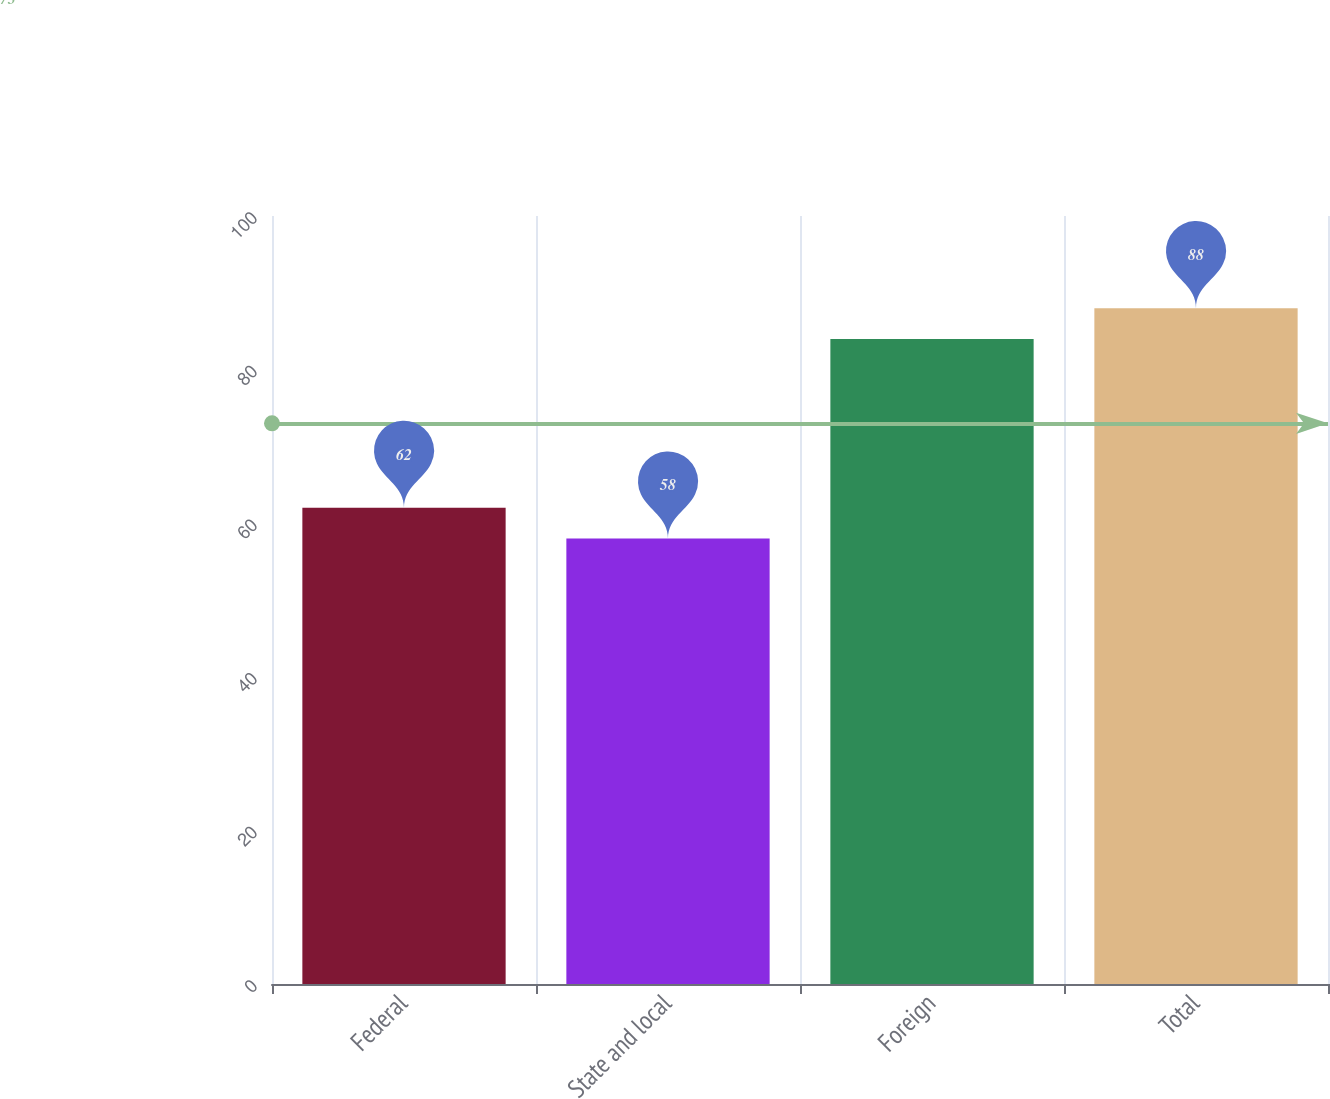<chart> <loc_0><loc_0><loc_500><loc_500><bar_chart><fcel>Federal<fcel>State and local<fcel>Foreign<fcel>Total<nl><fcel>62<fcel>58<fcel>84<fcel>88<nl></chart> 